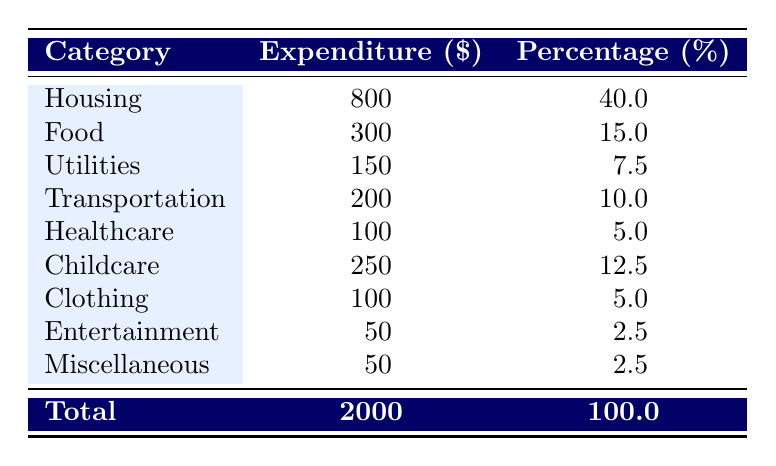What is the total household expenditure for low-income families? The total household expenditure is directly listed at the bottom of the table and is indicated as 2000.
Answer: 2000 What category has the highest expenditure? The category with the highest expenditure is Housing, which is listed at 800.
Answer: Housing What percentage of the total expenditure is allocated to Food? The percentage allocated to Food can be found in the table as 15.0, which is directly listed next to the Food expenditure.
Answer: 15.0 How much do low-income families spend on Childcare compared to Transportation? Childcare is 250 and Transportation is 200. The difference is 250 - 200 = 50. Thus, families spend 50 more on Childcare than Transportation.
Answer: 50 Is it true that low-income families spend more on Transportation than on Utilities? Transportation expenditure is 200, and Utilities expenditure is 150. Since 200 is greater than 150, the statement is true.
Answer: Yes What is the combined expenditure on Healthcare and Clothing? The expenditure for Healthcare is 100 and for Clothing is also 100. Adding these gives 100 + 100 = 200. Therefore, the combined expenditure is 200.
Answer: 200 What category accounts for the lowest percentage of total expenditure? Both Entertainment and Miscellaneous have the lowest percentage of 2.5, as listed in the table under their respective percentages.
Answer: Entertainment and Miscellaneous If the expenditure on Food increased by 50, what would be the new overall total expenditure? The original total expenditure is 2000. If Food increases by 50, the new total would be 2000 + 50 = 2050.
Answer: 2050 How much is spent on Utilities as a percentage of the total expenditure? Utilities expenditure is 150, and the total expenditure is 2000. Calculating the percentage gives (150/2000) * 100 = 7.5%, which matches the table.
Answer: 7.5 